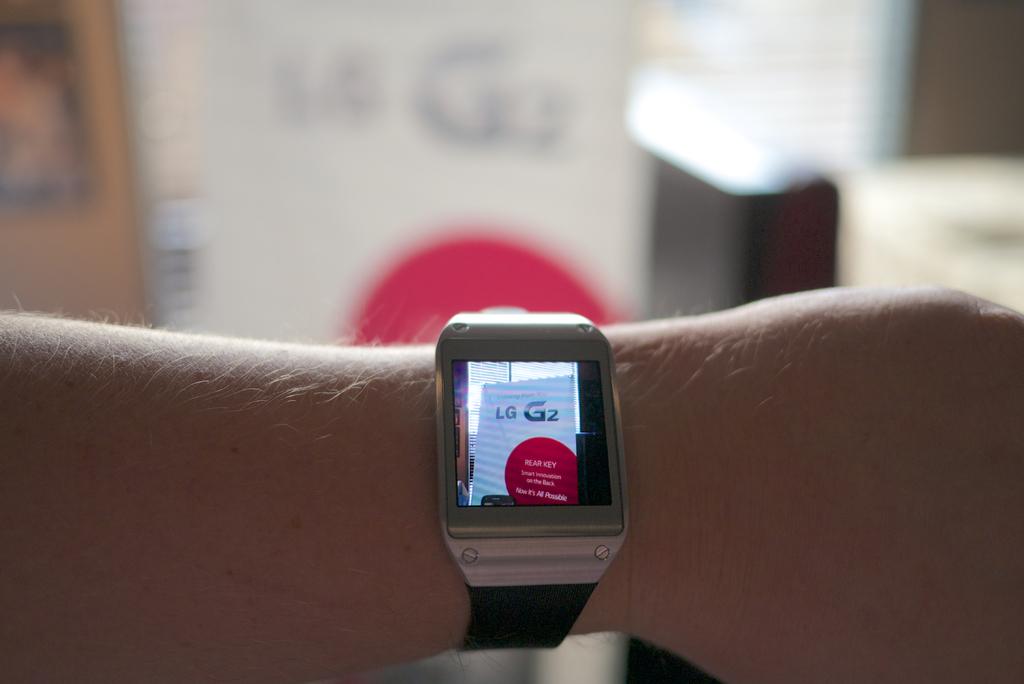What brand is displayed on the watch?
Provide a succinct answer. Lg. 